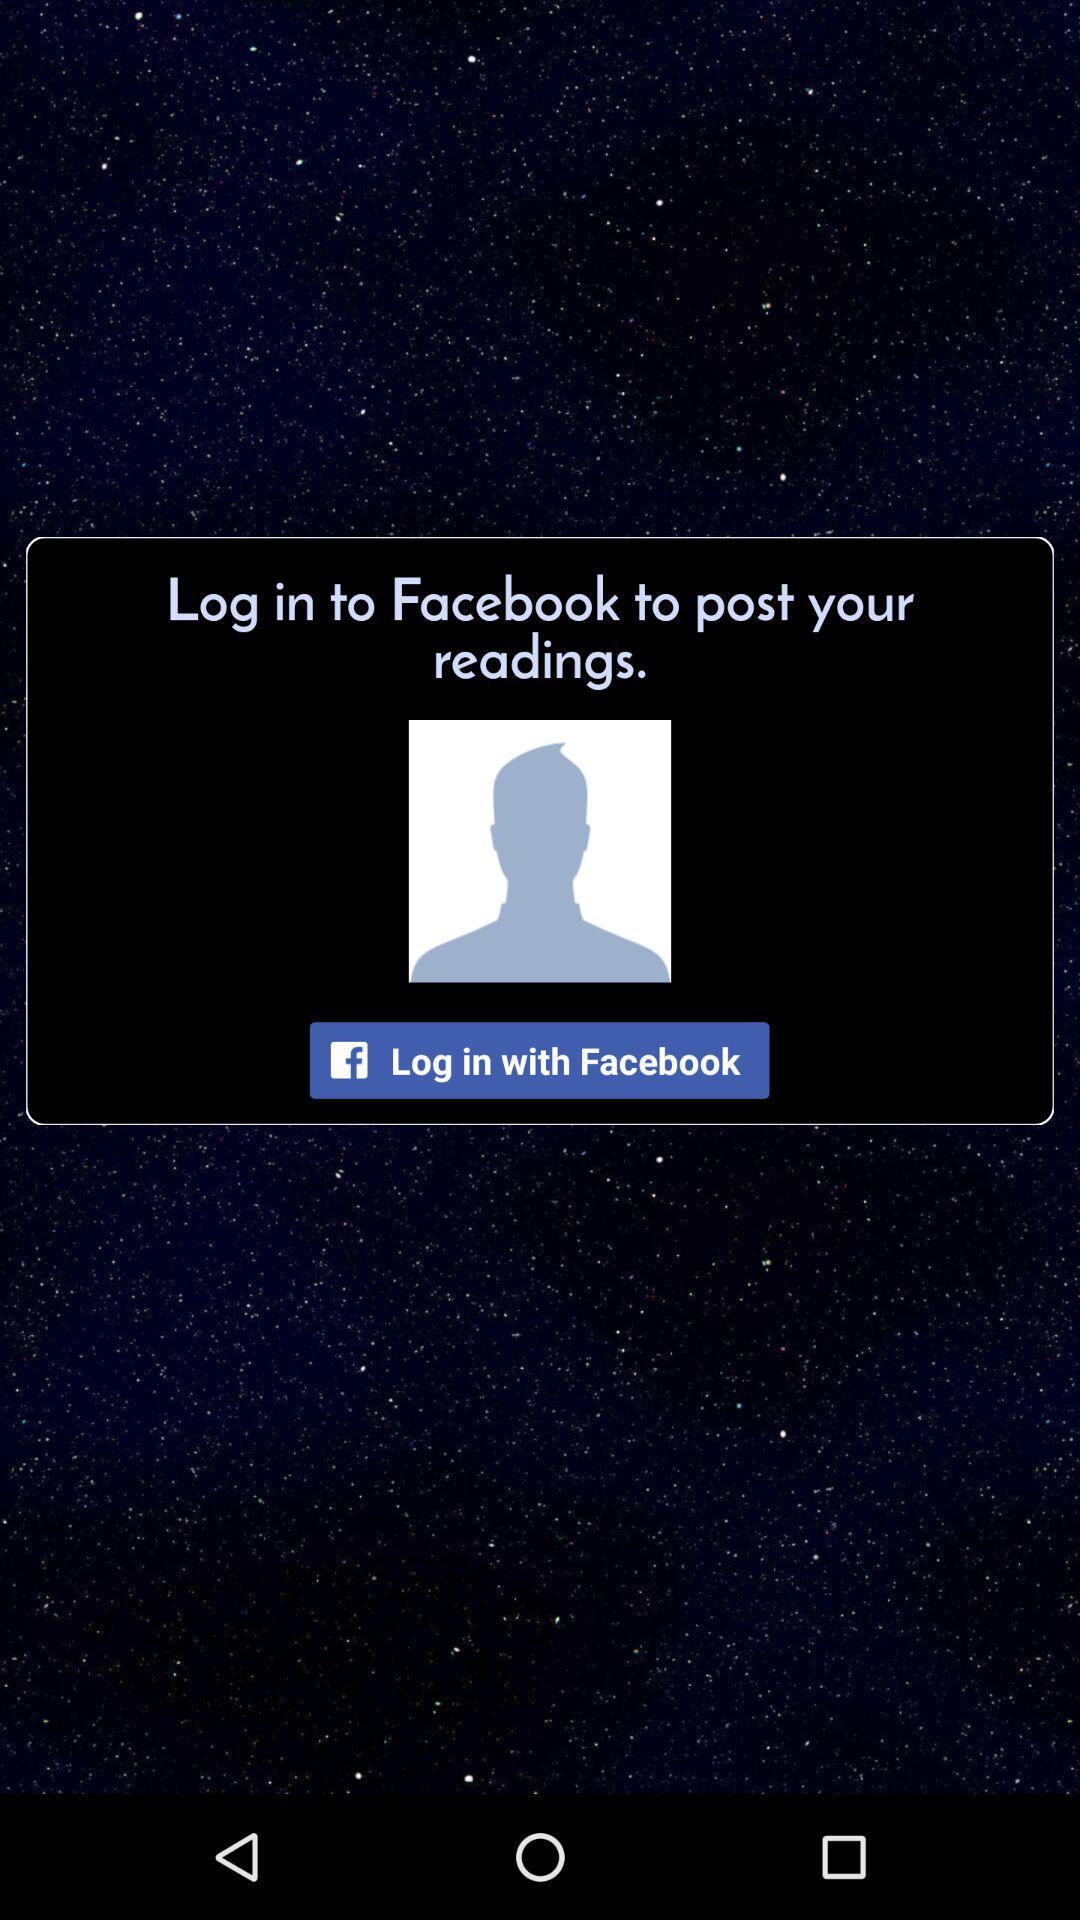How can we log in? You can login with "Facebook". 